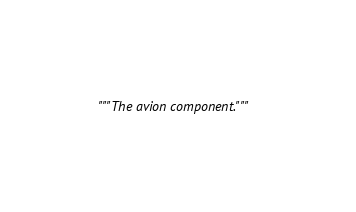<code> <loc_0><loc_0><loc_500><loc_500><_Python_>"""The avion component."""
</code> 